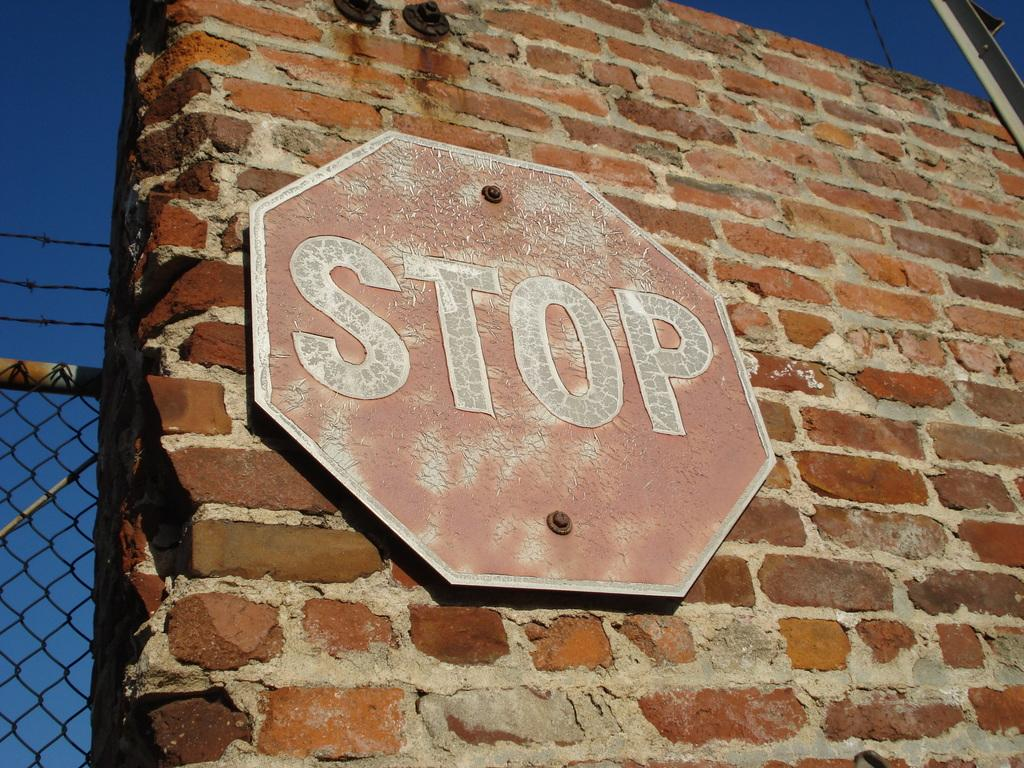Provide a one-sentence caption for the provided image. red stop sign mounted on a brick wall. 